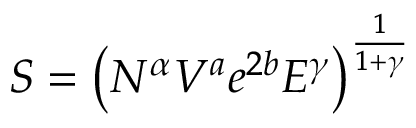<formula> <loc_0><loc_0><loc_500><loc_500>S = \left ( N ^ { \alpha } V ^ { a } e ^ { 2 b } E ^ { \gamma } \right ) ^ { \frac { 1 } { 1 + \gamma } }</formula> 